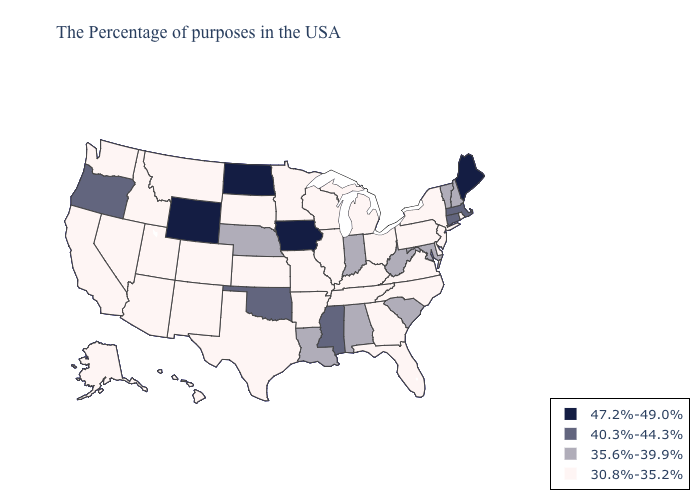Among the states that border Virginia , does Kentucky have the highest value?
Give a very brief answer. No. What is the value of Alaska?
Concise answer only. 30.8%-35.2%. Among the states that border Louisiana , does Mississippi have the lowest value?
Short answer required. No. What is the highest value in states that border Washington?
Quick response, please. 40.3%-44.3%. Does Florida have the highest value in the South?
Concise answer only. No. Does the map have missing data?
Concise answer only. No. What is the value of Virginia?
Write a very short answer. 30.8%-35.2%. What is the value of West Virginia?
Give a very brief answer. 35.6%-39.9%. Does Oregon have the lowest value in the USA?
Quick response, please. No. Among the states that border Pennsylvania , does Maryland have the lowest value?
Answer briefly. No. Which states have the highest value in the USA?
Short answer required. Maine, Iowa, North Dakota, Wyoming. What is the value of New Hampshire?
Be succinct. 35.6%-39.9%. Name the states that have a value in the range 40.3%-44.3%?
Short answer required. Massachusetts, Connecticut, Mississippi, Oklahoma, Oregon. Does North Carolina have the same value as Iowa?
Give a very brief answer. No. Does Connecticut have the lowest value in the USA?
Quick response, please. No. 